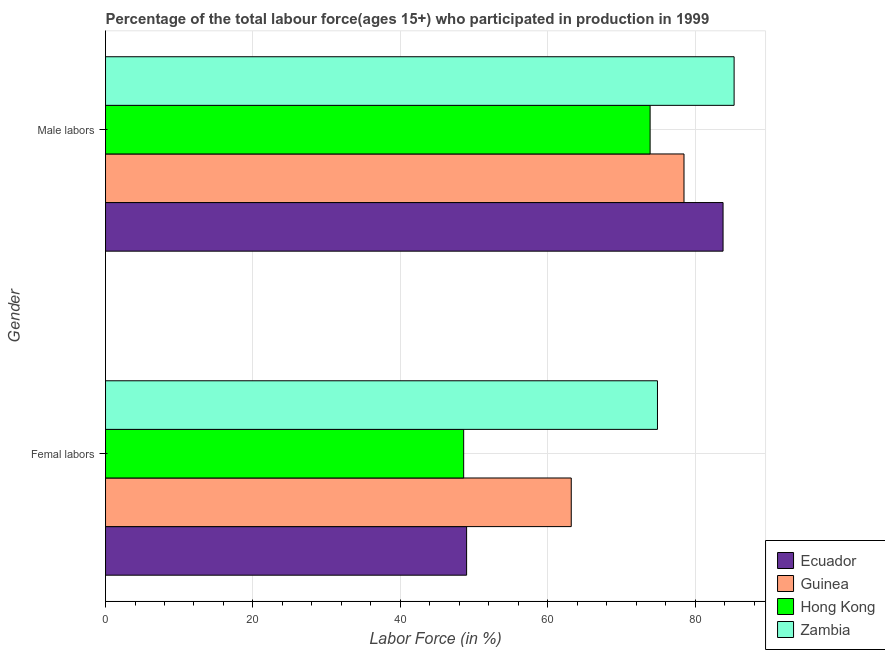How many groups of bars are there?
Your response must be concise. 2. Are the number of bars on each tick of the Y-axis equal?
Offer a terse response. Yes. How many bars are there on the 1st tick from the top?
Make the answer very short. 4. What is the label of the 1st group of bars from the top?
Keep it short and to the point. Male labors. What is the percentage of male labour force in Zambia?
Your response must be concise. 85.3. Across all countries, what is the maximum percentage of female labor force?
Offer a terse response. 74.9. Across all countries, what is the minimum percentage of female labor force?
Offer a terse response. 48.6. In which country was the percentage of female labor force maximum?
Offer a terse response. Zambia. In which country was the percentage of female labor force minimum?
Keep it short and to the point. Hong Kong. What is the total percentage of male labour force in the graph?
Provide a succinct answer. 321.5. What is the difference between the percentage of female labor force in Hong Kong and that in Guinea?
Make the answer very short. -14.6. What is the difference between the percentage of male labour force in Hong Kong and the percentage of female labor force in Ecuador?
Offer a very short reply. 24.9. What is the average percentage of male labour force per country?
Ensure brevity in your answer.  80.38. What is the difference between the percentage of female labor force and percentage of male labour force in Zambia?
Your answer should be very brief. -10.4. In how many countries, is the percentage of female labor force greater than 40 %?
Make the answer very short. 4. What is the ratio of the percentage of male labour force in Hong Kong to that in Ecuador?
Provide a succinct answer. 0.88. Is the percentage of female labor force in Zambia less than that in Guinea?
Your answer should be very brief. No. In how many countries, is the percentage of female labor force greater than the average percentage of female labor force taken over all countries?
Make the answer very short. 2. What does the 4th bar from the top in Femal labors represents?
Make the answer very short. Ecuador. What does the 4th bar from the bottom in Male labors represents?
Give a very brief answer. Zambia. How many bars are there?
Your answer should be compact. 8. Are all the bars in the graph horizontal?
Provide a succinct answer. Yes. How many countries are there in the graph?
Your answer should be compact. 4. Does the graph contain any zero values?
Your response must be concise. No. How many legend labels are there?
Ensure brevity in your answer.  4. How are the legend labels stacked?
Your answer should be very brief. Vertical. What is the title of the graph?
Provide a succinct answer. Percentage of the total labour force(ages 15+) who participated in production in 1999. What is the Labor Force (in %) of Guinea in Femal labors?
Offer a very short reply. 63.2. What is the Labor Force (in %) in Hong Kong in Femal labors?
Your answer should be compact. 48.6. What is the Labor Force (in %) of Zambia in Femal labors?
Your response must be concise. 74.9. What is the Labor Force (in %) in Ecuador in Male labors?
Make the answer very short. 83.8. What is the Labor Force (in %) of Guinea in Male labors?
Make the answer very short. 78.5. What is the Labor Force (in %) of Hong Kong in Male labors?
Ensure brevity in your answer.  73.9. What is the Labor Force (in %) of Zambia in Male labors?
Offer a terse response. 85.3. Across all Gender, what is the maximum Labor Force (in %) in Ecuador?
Your answer should be very brief. 83.8. Across all Gender, what is the maximum Labor Force (in %) in Guinea?
Offer a terse response. 78.5. Across all Gender, what is the maximum Labor Force (in %) in Hong Kong?
Make the answer very short. 73.9. Across all Gender, what is the maximum Labor Force (in %) in Zambia?
Provide a succinct answer. 85.3. Across all Gender, what is the minimum Labor Force (in %) of Guinea?
Your response must be concise. 63.2. Across all Gender, what is the minimum Labor Force (in %) of Hong Kong?
Give a very brief answer. 48.6. Across all Gender, what is the minimum Labor Force (in %) in Zambia?
Offer a very short reply. 74.9. What is the total Labor Force (in %) in Ecuador in the graph?
Give a very brief answer. 132.8. What is the total Labor Force (in %) of Guinea in the graph?
Your answer should be very brief. 141.7. What is the total Labor Force (in %) of Hong Kong in the graph?
Your response must be concise. 122.5. What is the total Labor Force (in %) in Zambia in the graph?
Provide a succinct answer. 160.2. What is the difference between the Labor Force (in %) of Ecuador in Femal labors and that in Male labors?
Offer a terse response. -34.8. What is the difference between the Labor Force (in %) of Guinea in Femal labors and that in Male labors?
Provide a succinct answer. -15.3. What is the difference between the Labor Force (in %) in Hong Kong in Femal labors and that in Male labors?
Provide a short and direct response. -25.3. What is the difference between the Labor Force (in %) of Ecuador in Femal labors and the Labor Force (in %) of Guinea in Male labors?
Offer a terse response. -29.5. What is the difference between the Labor Force (in %) in Ecuador in Femal labors and the Labor Force (in %) in Hong Kong in Male labors?
Ensure brevity in your answer.  -24.9. What is the difference between the Labor Force (in %) of Ecuador in Femal labors and the Labor Force (in %) of Zambia in Male labors?
Ensure brevity in your answer.  -36.3. What is the difference between the Labor Force (in %) in Guinea in Femal labors and the Labor Force (in %) in Hong Kong in Male labors?
Your answer should be compact. -10.7. What is the difference between the Labor Force (in %) in Guinea in Femal labors and the Labor Force (in %) in Zambia in Male labors?
Provide a short and direct response. -22.1. What is the difference between the Labor Force (in %) in Hong Kong in Femal labors and the Labor Force (in %) in Zambia in Male labors?
Provide a short and direct response. -36.7. What is the average Labor Force (in %) in Ecuador per Gender?
Ensure brevity in your answer.  66.4. What is the average Labor Force (in %) in Guinea per Gender?
Ensure brevity in your answer.  70.85. What is the average Labor Force (in %) in Hong Kong per Gender?
Make the answer very short. 61.25. What is the average Labor Force (in %) of Zambia per Gender?
Your response must be concise. 80.1. What is the difference between the Labor Force (in %) in Ecuador and Labor Force (in %) in Zambia in Femal labors?
Your response must be concise. -25.9. What is the difference between the Labor Force (in %) of Guinea and Labor Force (in %) of Hong Kong in Femal labors?
Keep it short and to the point. 14.6. What is the difference between the Labor Force (in %) of Hong Kong and Labor Force (in %) of Zambia in Femal labors?
Make the answer very short. -26.3. What is the difference between the Labor Force (in %) of Ecuador and Labor Force (in %) of Guinea in Male labors?
Provide a short and direct response. 5.3. What is the difference between the Labor Force (in %) in Guinea and Labor Force (in %) in Hong Kong in Male labors?
Provide a short and direct response. 4.6. What is the difference between the Labor Force (in %) of Hong Kong and Labor Force (in %) of Zambia in Male labors?
Keep it short and to the point. -11.4. What is the ratio of the Labor Force (in %) of Ecuador in Femal labors to that in Male labors?
Ensure brevity in your answer.  0.58. What is the ratio of the Labor Force (in %) in Guinea in Femal labors to that in Male labors?
Your answer should be compact. 0.81. What is the ratio of the Labor Force (in %) in Hong Kong in Femal labors to that in Male labors?
Your response must be concise. 0.66. What is the ratio of the Labor Force (in %) in Zambia in Femal labors to that in Male labors?
Ensure brevity in your answer.  0.88. What is the difference between the highest and the second highest Labor Force (in %) of Ecuador?
Provide a succinct answer. 34.8. What is the difference between the highest and the second highest Labor Force (in %) of Guinea?
Your answer should be compact. 15.3. What is the difference between the highest and the second highest Labor Force (in %) of Hong Kong?
Keep it short and to the point. 25.3. What is the difference between the highest and the second highest Labor Force (in %) in Zambia?
Offer a very short reply. 10.4. What is the difference between the highest and the lowest Labor Force (in %) in Ecuador?
Ensure brevity in your answer.  34.8. What is the difference between the highest and the lowest Labor Force (in %) of Hong Kong?
Offer a very short reply. 25.3. 